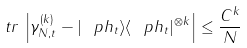<formula> <loc_0><loc_0><loc_500><loc_500>\ t r \, \left | \gamma _ { N , t } ^ { ( k ) } - | \ p h _ { t } \rangle \langle \ p h _ { t } | ^ { \otimes k } \right | \leq \frac { C ^ { k } } { N }</formula> 